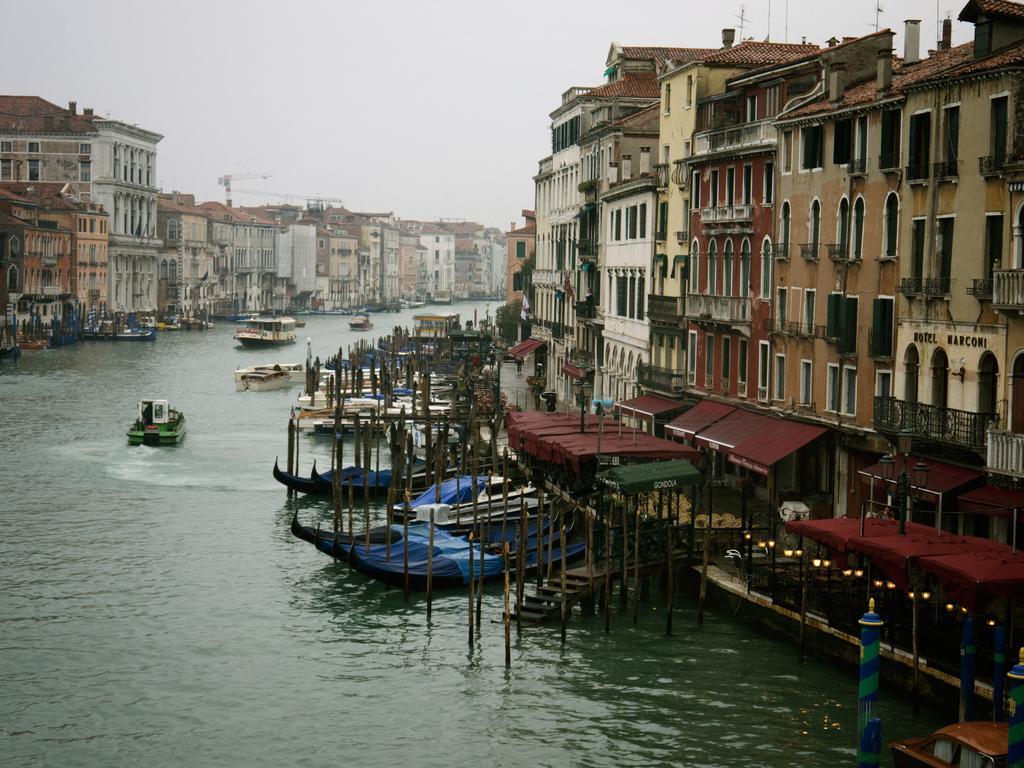Describe this image in one or two sentences. In the center of the image there is a canal and we can see boats on the canal. In the background there are buildings and sky. 